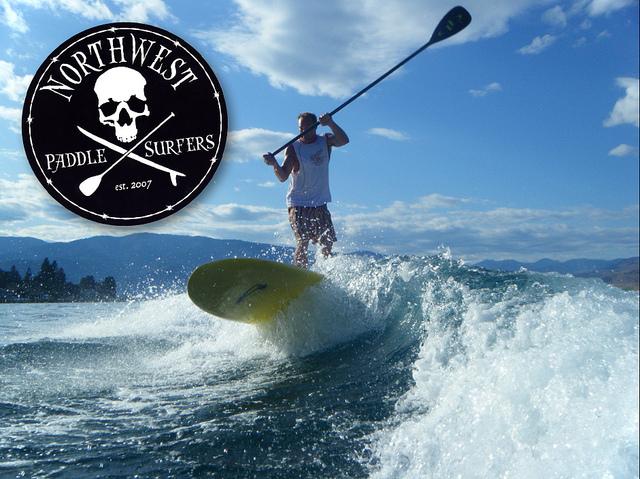Is this an advertisement?
Quick response, please. Yes. What color is the surfboard?
Write a very short answer. Yellow. What is the person holding?
Write a very short answer. Paddle. 